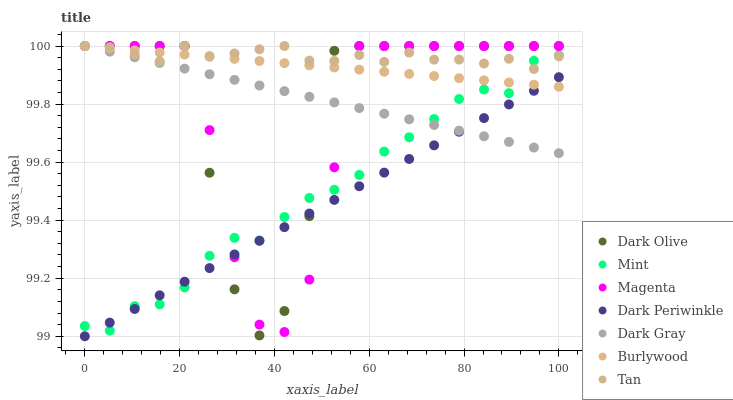Does Dark Periwinkle have the minimum area under the curve?
Answer yes or no. Yes. Does Tan have the maximum area under the curve?
Answer yes or no. Yes. Does Dark Olive have the minimum area under the curve?
Answer yes or no. No. Does Dark Olive have the maximum area under the curve?
Answer yes or no. No. Is Burlywood the smoothest?
Answer yes or no. Yes. Is Dark Olive the roughest?
Answer yes or no. Yes. Is Dark Gray the smoothest?
Answer yes or no. No. Is Dark Gray the roughest?
Answer yes or no. No. Does Dark Periwinkle have the lowest value?
Answer yes or no. Yes. Does Dark Olive have the lowest value?
Answer yes or no. No. Does Magenta have the highest value?
Answer yes or no. Yes. Does Mint have the highest value?
Answer yes or no. No. Is Dark Periwinkle less than Tan?
Answer yes or no. Yes. Is Tan greater than Dark Periwinkle?
Answer yes or no. Yes. Does Magenta intersect Dark Gray?
Answer yes or no. Yes. Is Magenta less than Dark Gray?
Answer yes or no. No. Is Magenta greater than Dark Gray?
Answer yes or no. No. Does Dark Periwinkle intersect Tan?
Answer yes or no. No. 